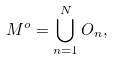<formula> <loc_0><loc_0><loc_500><loc_500>M ^ { o } = \bigcup _ { n = 1 } ^ { N } O _ { n } ,</formula> 